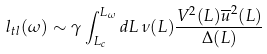<formula> <loc_0><loc_0><loc_500><loc_500>l _ { t l } ( \omega ) \sim { \gamma } \int ^ { L _ { \omega } } _ { L _ { c } } d L \, \nu ( L ) \frac { V ^ { 2 } ( L ) \overline { u } ^ { 2 } ( L ) } { \Delta ( L ) }</formula> 